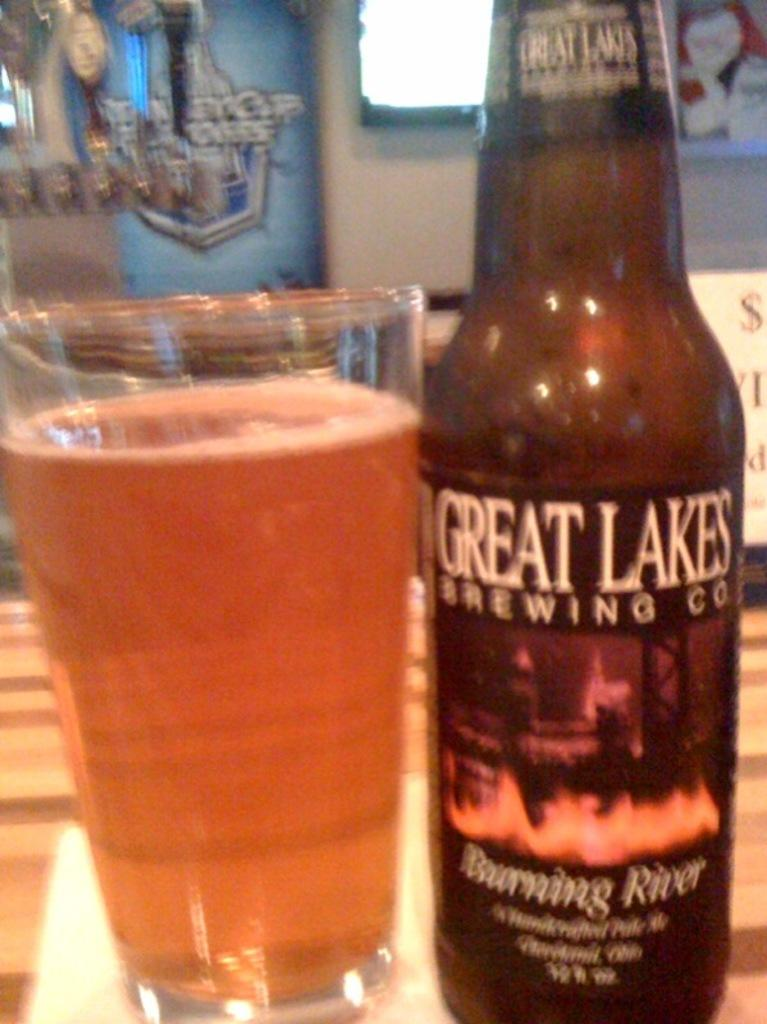<image>
Relay a brief, clear account of the picture shown. A bottle and glass of Great Lakes Brewing Co beer 